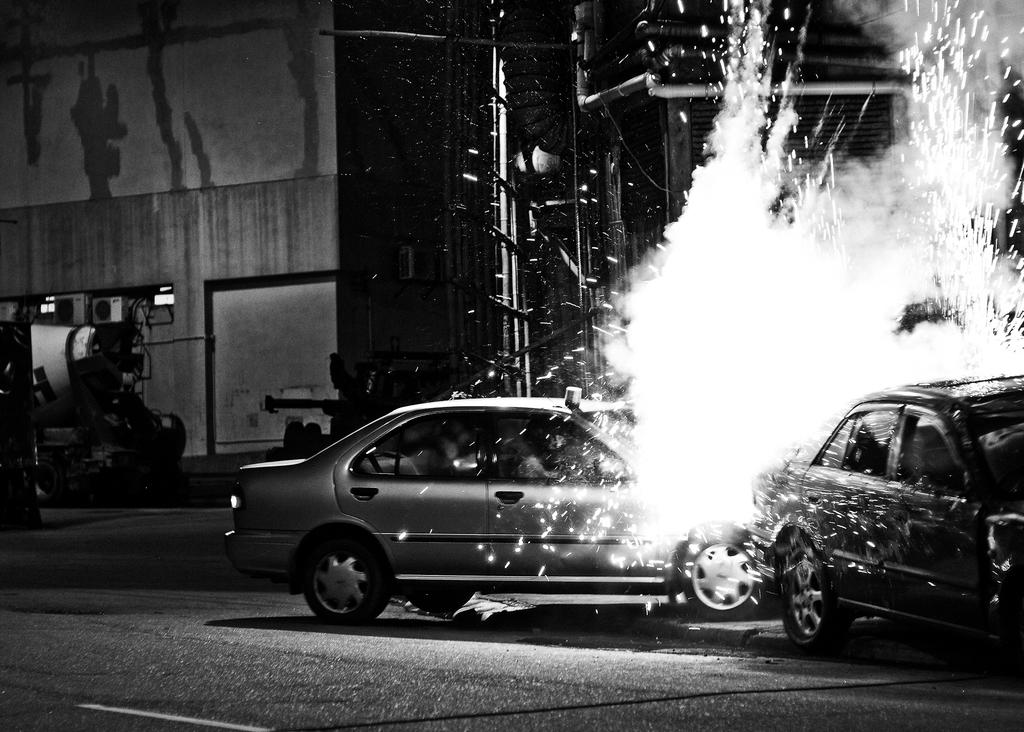How many cars can be seen in the image? There are two cars in the image. What is happening on the road in the image? There is a fire on the road in the image. What can be seen in the background of the image? There are buildings, light poles, and metal rods visible in the background of the image. Where was the image likely taken? The image appears to be taken on a road. Is there a woman standing next to the fire in the image? There is no woman present in the image; it only shows two cars, a fire on the road, and background elements. What type of battle is taking place in the image? There is no battle depicted in the image; it shows a fire on the road and two cars. 